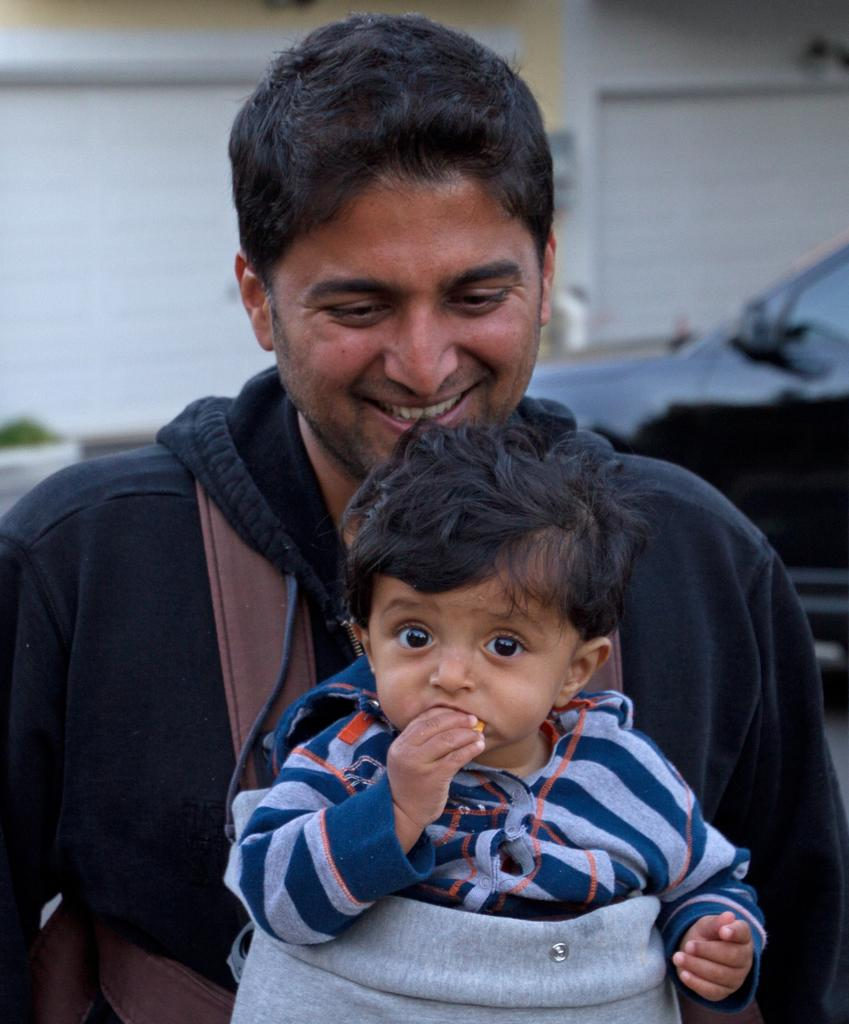What is the person in the image doing with the baby? The person is holding a baby in the image. How is the person holding the baby? The person is using a bag to hold the baby. What can be seen in the background of the image? There is a vehicle moving on the road and a wall visible in the background of the image. What type of coast can be seen in the image? There is no coast visible in the image; it features a person holding a baby and a background with a vehicle and a wall. 